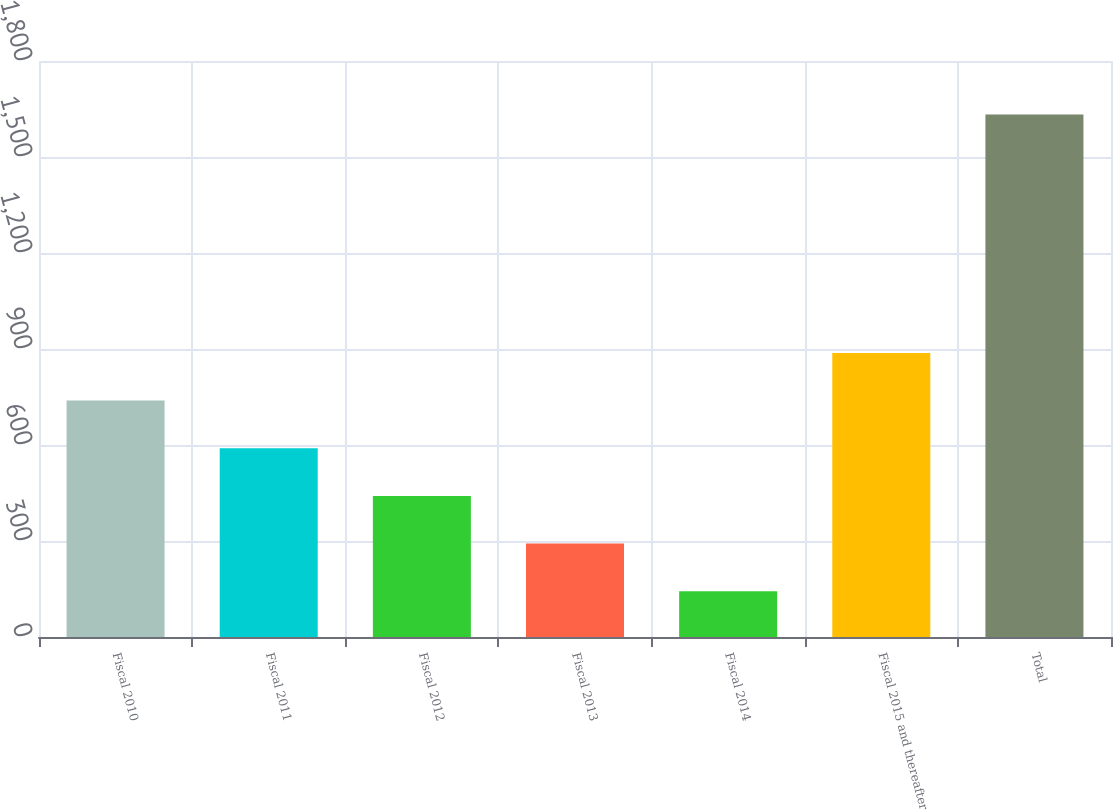Convert chart. <chart><loc_0><loc_0><loc_500><loc_500><bar_chart><fcel>Fiscal 2010<fcel>Fiscal 2011<fcel>Fiscal 2012<fcel>Fiscal 2013<fcel>Fiscal 2014<fcel>Fiscal 2015 and thereafter<fcel>Total<nl><fcel>738.84<fcel>589.88<fcel>440.92<fcel>291.96<fcel>143<fcel>887.8<fcel>1632.6<nl></chart> 